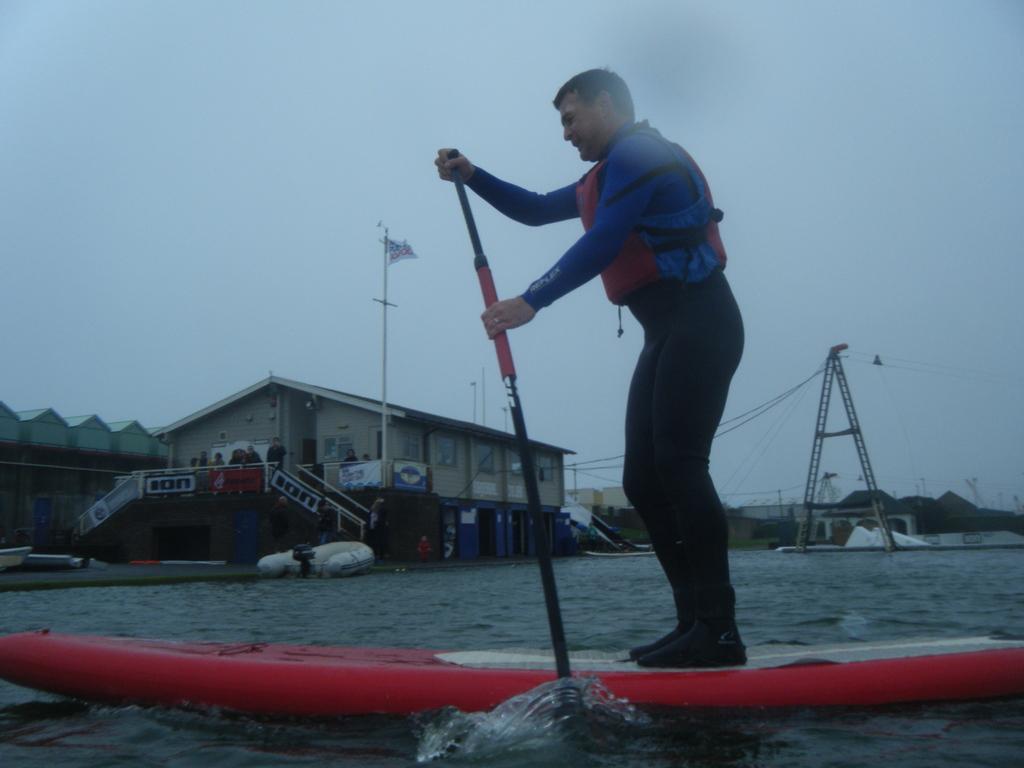How would you summarize this image in a sentence or two? Here we can see a man standing on kayak and paddling on the water. In the background there are buildings,hoardings,boats on the water,big poles,electric wires,some other objects and sky. 